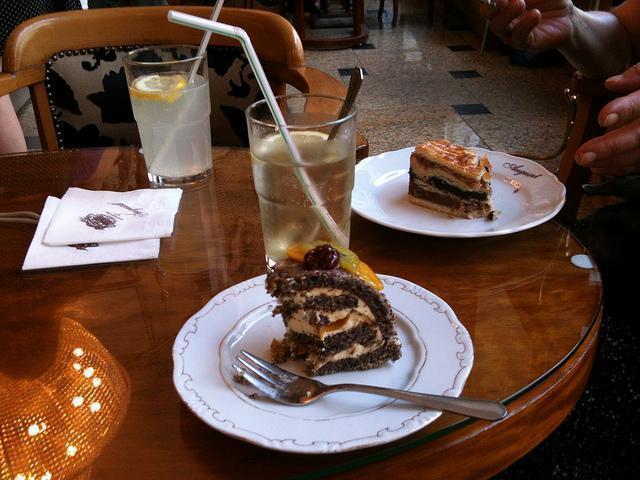How do you say the name of the item on the plate next to the cake in Italian?
From the following set of four choices, select the accurate answer to respond to the question.
Options: Cucchiaio, grazie, spoon, forchetta. Forchetta. 